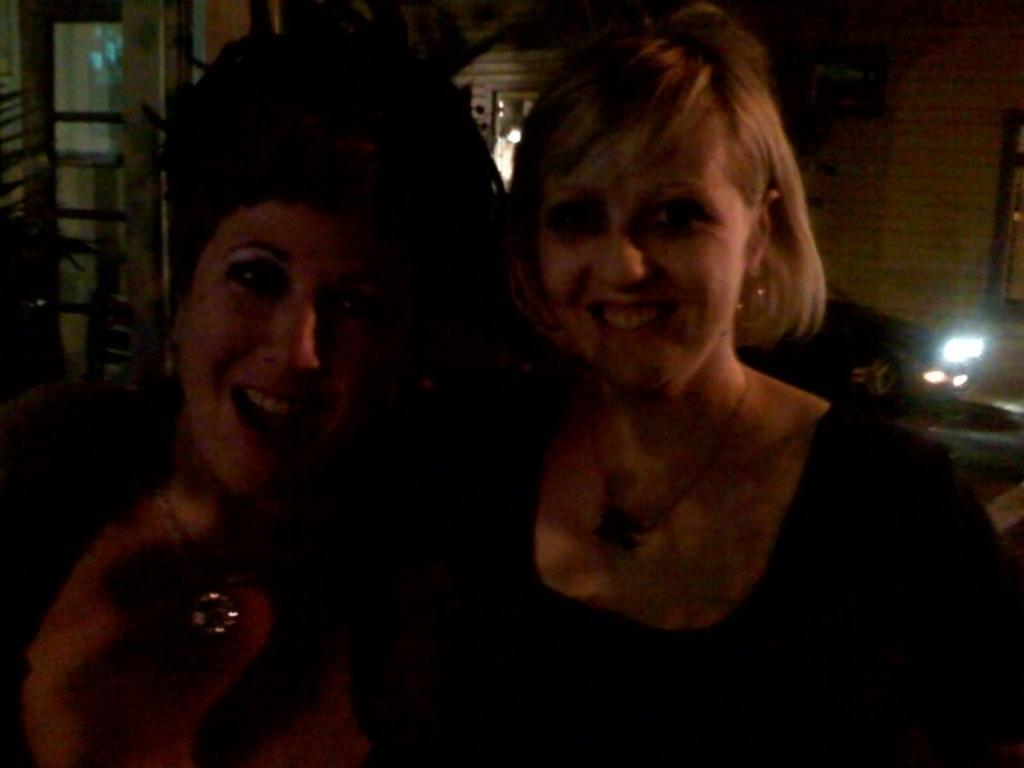How many people are in the image? There are two people in the image. What is the facial expression of the people in the image? The people are smiling. What can be seen in the image besides the people? There is light visible in the image, as well as plants and objects around the people. What is the uncle thinking about in the image? There is no uncle present in the image, so it is not possible to determine what the uncle might be thinking. 